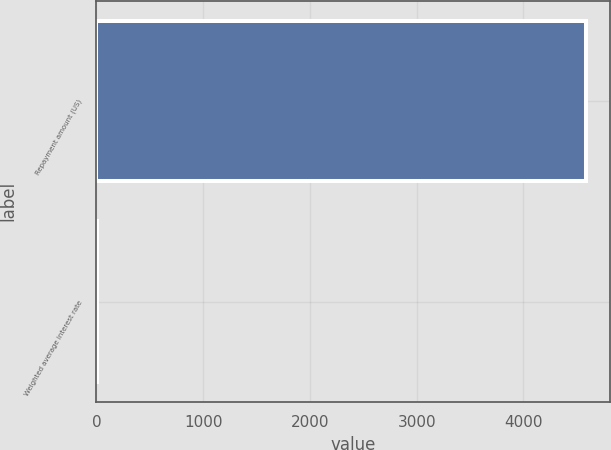<chart> <loc_0><loc_0><loc_500><loc_500><bar_chart><fcel>Repayment amount (US)<fcel>Weighted average interest rate<nl><fcel>4584<fcel>6.6<nl></chart> 